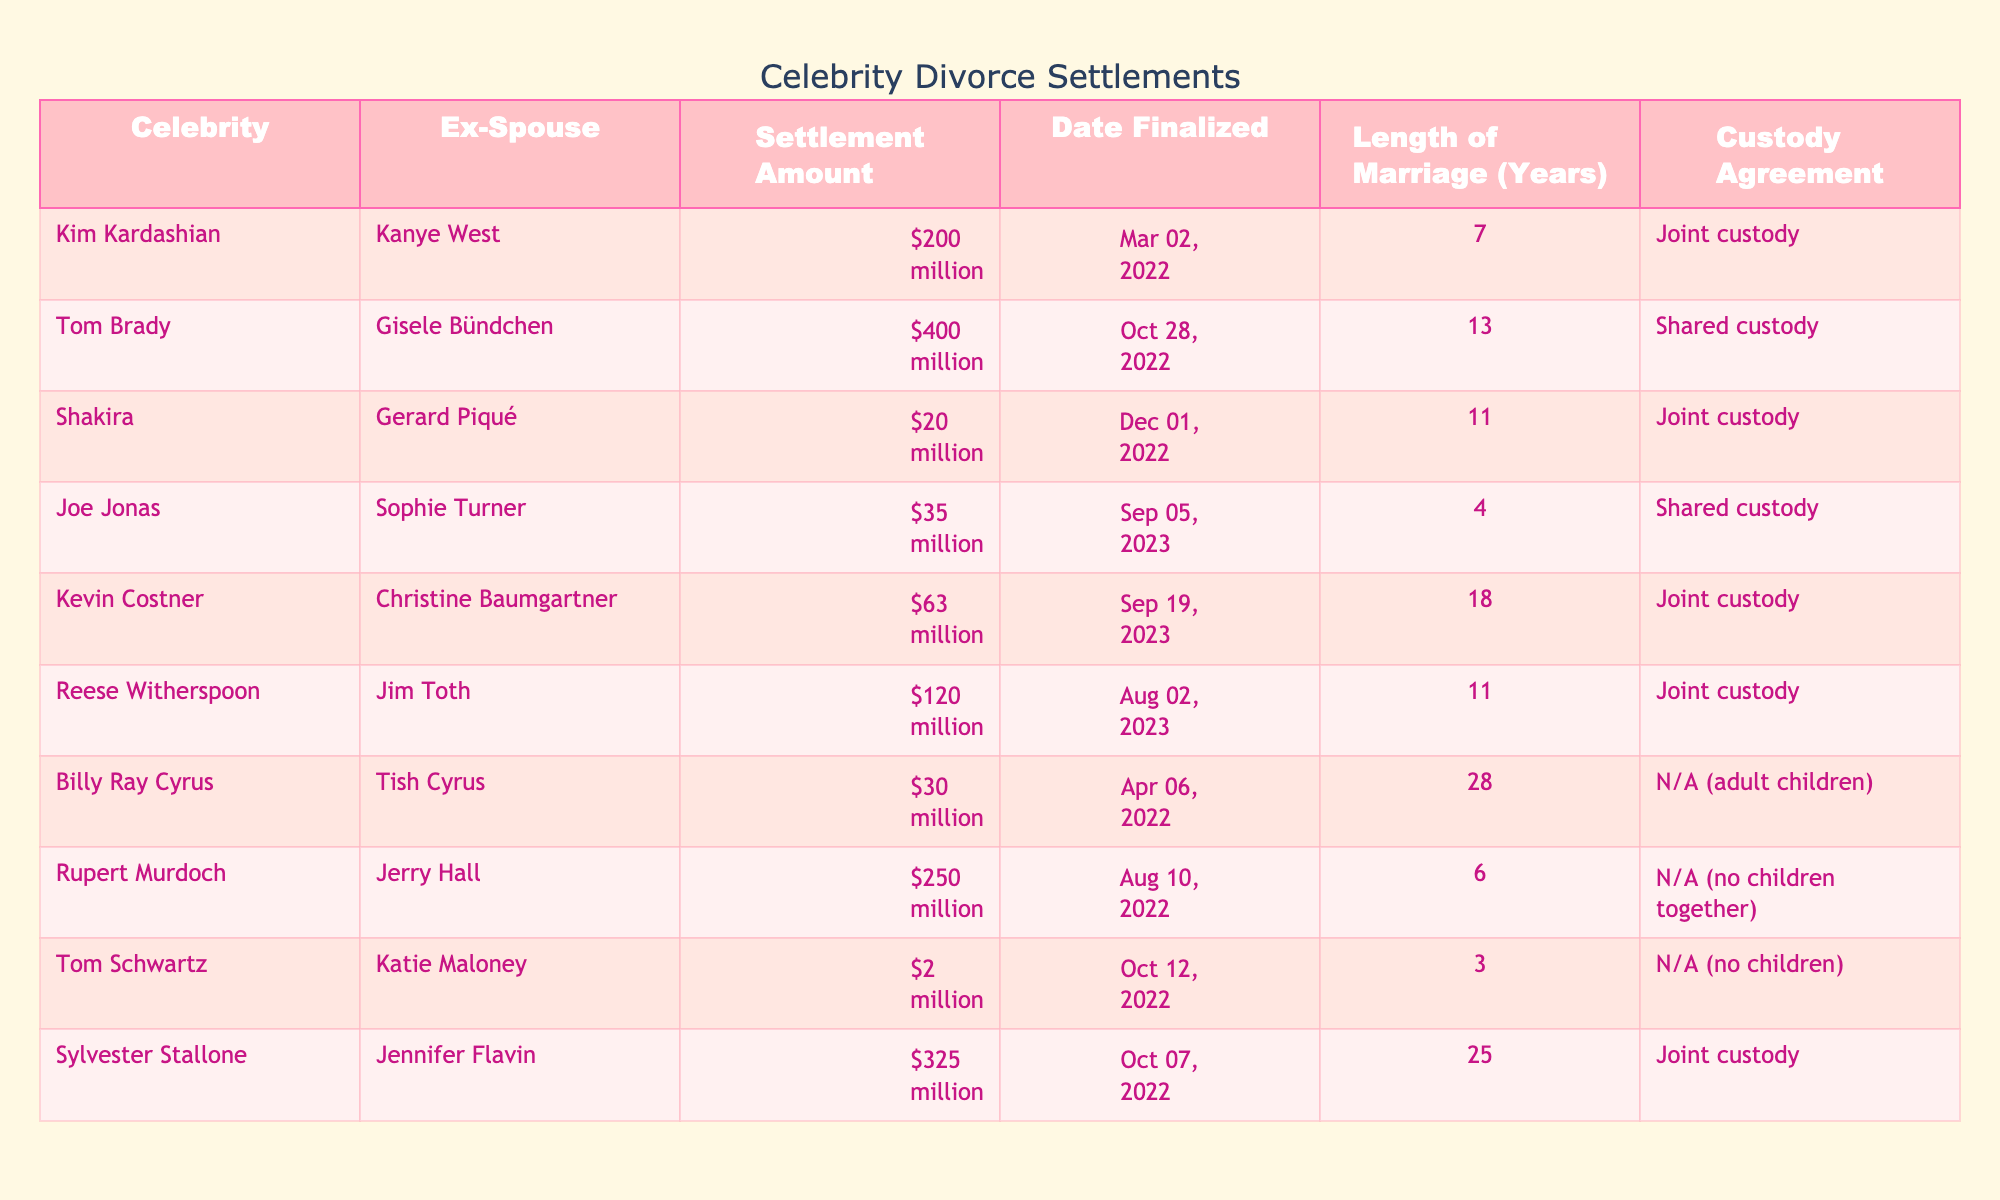What is the highest settlement amount among these celebrity divorces? The table shows various settlement amounts, and by comparing them, the highest amount appears to be Tom Brady and Gisele Bündchen's settlement of $400 million.
Answer: $400 million Which celebrity has the shortest marriage before their divorce? By examining the "Length of Marriage" column, Joe Jonas and Sophie Turner's marriage lasted only 4 years, which is the shortest compared to the other couples.
Answer: 4 years Were Kim Kardashian and Kanye West given joint custody of their children? According to the "Custody Agreement" column, the entry for Kim Kardashian and Kanye West indicates they have a joint custody agreement.
Answer: Yes How much did Sylvester Stallone and Jennifer Flavin settle for? The table lists Sylvester Stallone and Jennifer Flavin's settlement as $325 million.
Answer: $325 million What is the average settlement amount of all the celebrities listed? First, we sum up all the settlement amounts: $200m + $400m + $20m + $35m + $63m + $120m + $30m + $250m + $2m + $325m = $1,415 million. There are 10 settlements, so the average is calculated as $1,415 million / 10 = $141.5 million.
Answer: $141.5 million How many couples had joint custody agreements? By checking the "Custody Agreement" column, we find that Kim Kardashian and Kanye West, Shakira and Gerard Piqué, Kevin Costner and Christine Baumgartner, Reese Witherspoon and Jim Toth, and Sylvester Stallone and Jennifer Flavin all have joint custody agreements. That makes it 5 couples.
Answer: 5 couples Which divorce settlement was finalized in the year with the most total settlements listed? Analyzing the "Date Finalized" column, 2022 has 7 finalized settlements while 2023 only has 3. Therefore, 2022 is the year with the most settlements.
Answer: 2022 Is there a celebrity on the list whose divorce involved no children? The table indicates that both Tom Schwartz and Billy Ray Cyrus have "N/A (no children together)" listed in the "Custody Agreement" column, confirming they had no children in their divorce settlements.
Answer: Yes What was the total settlement amount for the people who finalized their divorces in 2023? First, we identify the settlements finalized in 2023, which are $35 million (Joe Jonas), $63 million (Kevin Costner), and $120 million (Reese Witherspoon). Summing these gives $35m + $63m + $120m = $218 million.
Answer: $218 million Which celebrity was married the longest before their divorce? The table details that Billy Ray Cyrus and Tish Cyrus were married for 28 years, which is longer than any other marriage listed.
Answer: 28 years 